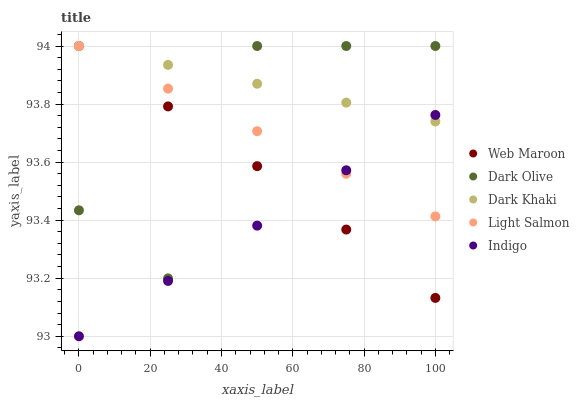Does Indigo have the minimum area under the curve?
Answer yes or no. Yes. Does Dark Khaki have the maximum area under the curve?
Answer yes or no. Yes. Does Light Salmon have the minimum area under the curve?
Answer yes or no. No. Does Light Salmon have the maximum area under the curve?
Answer yes or no. No. Is Dark Khaki the smoothest?
Answer yes or no. Yes. Is Dark Olive the roughest?
Answer yes or no. Yes. Is Indigo the smoothest?
Answer yes or no. No. Is Indigo the roughest?
Answer yes or no. No. Does Indigo have the lowest value?
Answer yes or no. Yes. Does Light Salmon have the lowest value?
Answer yes or no. No. Does Web Maroon have the highest value?
Answer yes or no. Yes. Does Indigo have the highest value?
Answer yes or no. No. Is Indigo less than Dark Olive?
Answer yes or no. Yes. Is Dark Olive greater than Indigo?
Answer yes or no. Yes. Does Dark Olive intersect Web Maroon?
Answer yes or no. Yes. Is Dark Olive less than Web Maroon?
Answer yes or no. No. Is Dark Olive greater than Web Maroon?
Answer yes or no. No. Does Indigo intersect Dark Olive?
Answer yes or no. No. 